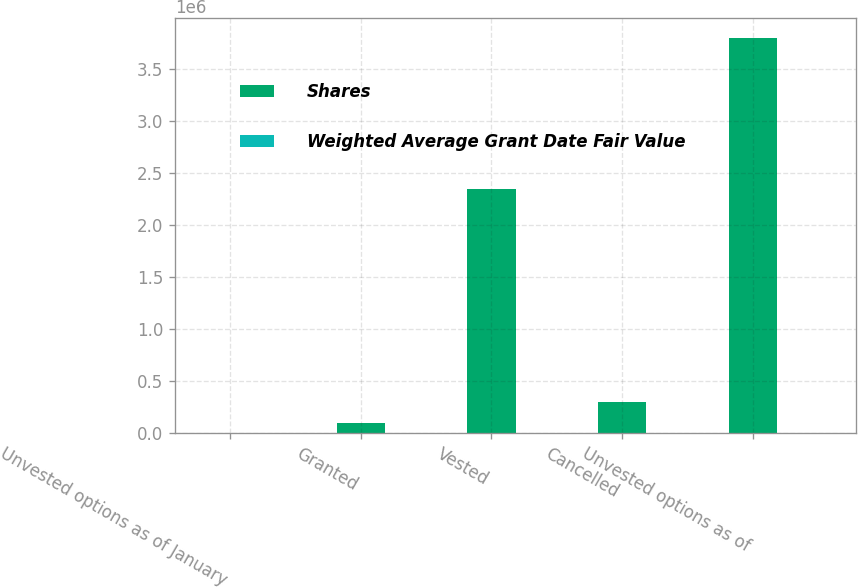Convert chart to OTSL. <chart><loc_0><loc_0><loc_500><loc_500><stacked_bar_chart><ecel><fcel>Unvested options as of January<fcel>Granted<fcel>Vested<fcel>Cancelled<fcel>Unvested options as of<nl><fcel>Shares<fcel>7.84<fcel>94000<fcel>2.3445e+06<fcel>295750<fcel>3.79925e+06<nl><fcel>Weighted Average Grant Date Fair Value<fcel>5.75<fcel>7.84<fcel>5.74<fcel>5.69<fcel>5.8<nl></chart> 